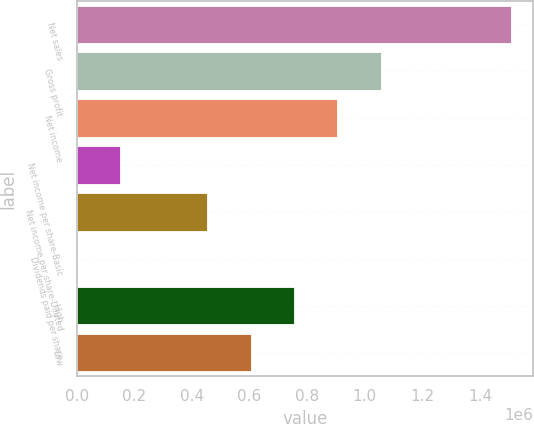Convert chart to OTSL. <chart><loc_0><loc_0><loc_500><loc_500><bar_chart><fcel>Net sales<fcel>Gross profit<fcel>Net income<fcel>Net income per share-Basic<fcel>Net income per share-Diluted<fcel>Dividends paid per share<fcel>High<fcel>Low<nl><fcel>1.50851e+06<fcel>1.05596e+06<fcel>905109<fcel>150852<fcel>452554<fcel>0.38<fcel>754257<fcel>603406<nl></chart> 